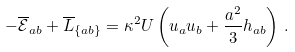Convert formula to latex. <formula><loc_0><loc_0><loc_500><loc_500>- \overline { \mathcal { E } } _ { a b } + \overline { L } _ { \{ a b \} } = \kappa ^ { 2 } U \left ( u _ { a } u _ { b } + \frac { a ^ { 2 } } { 3 } h _ { a b } \right ) \, .</formula> 